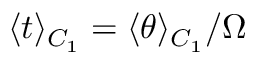Convert formula to latex. <formula><loc_0><loc_0><loc_500><loc_500>\langle t \rangle _ { C _ { 1 } } = \langle \theta \rangle _ { C _ { 1 } } / \Omega</formula> 